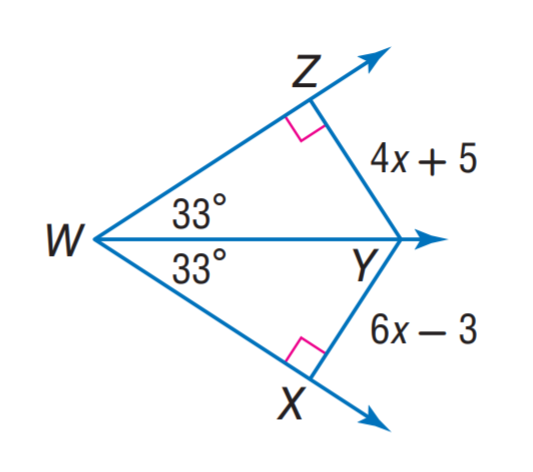Question: Find X Y.
Choices:
A. 21
B. 24
C. 33
D. 42
Answer with the letter. Answer: A 